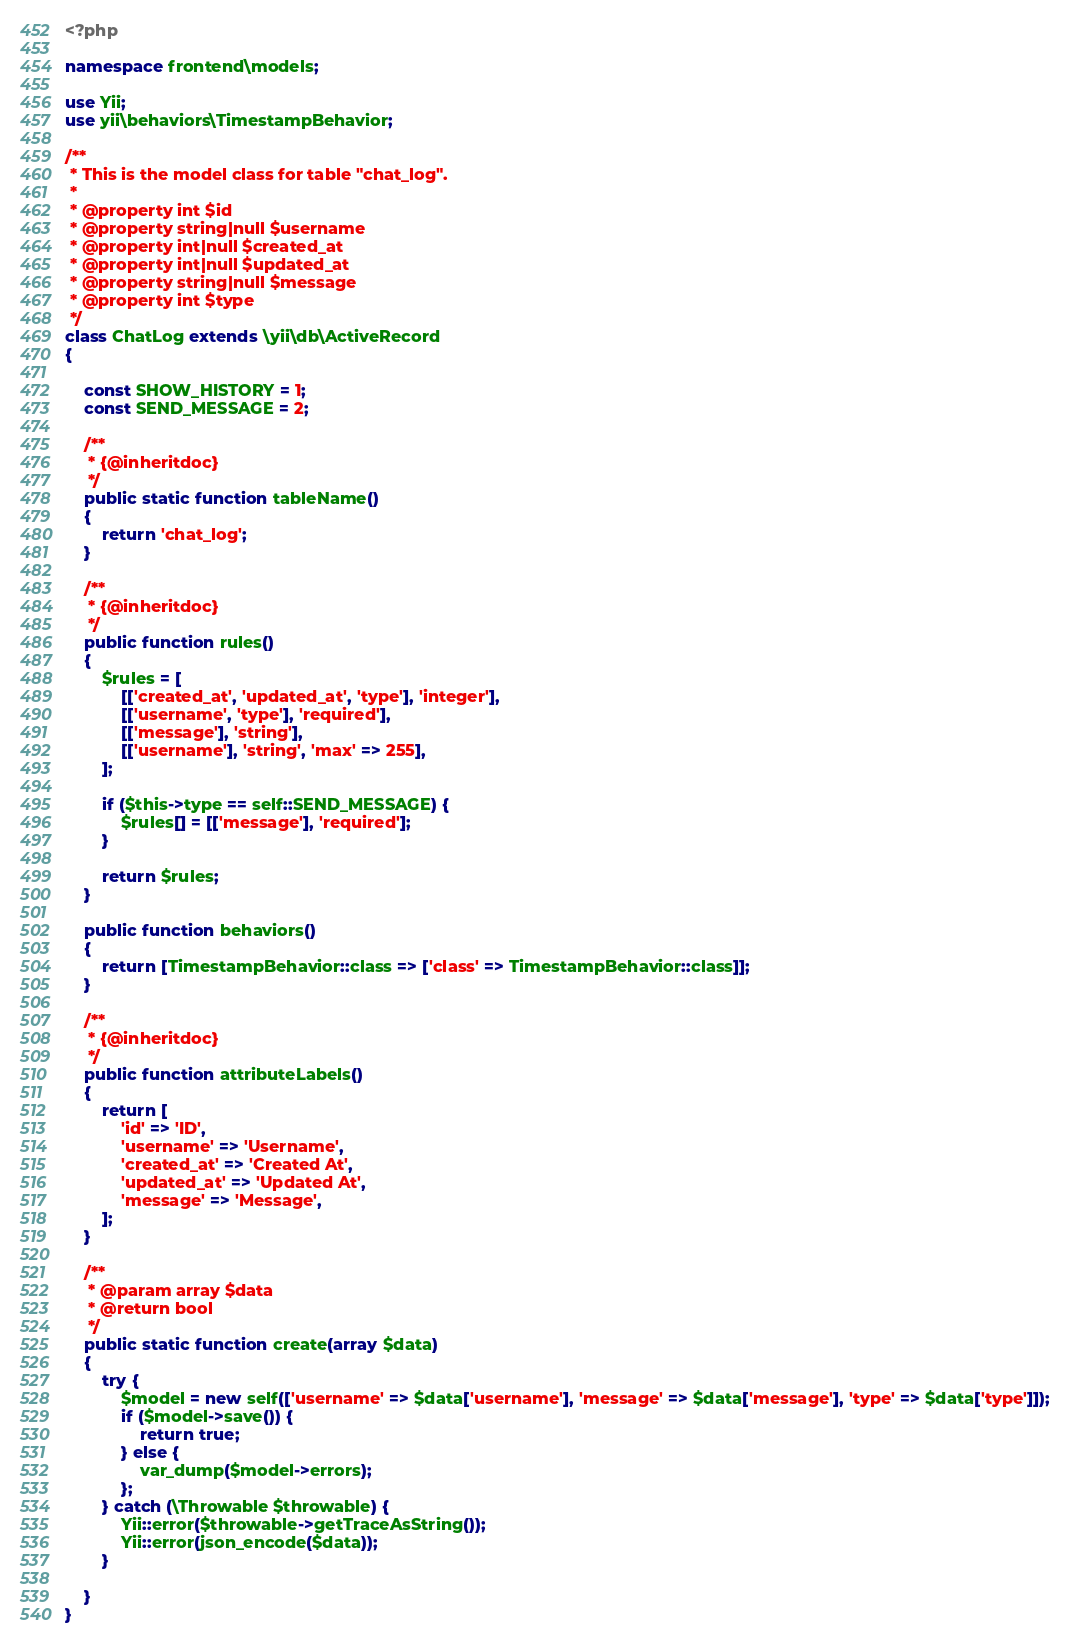<code> <loc_0><loc_0><loc_500><loc_500><_PHP_><?php

namespace frontend\models;

use Yii;
use yii\behaviors\TimestampBehavior;

/**
 * This is the model class for table "chat_log".
 *
 * @property int $id
 * @property string|null $username
 * @property int|null $created_at
 * @property int|null $updated_at
 * @property string|null $message
 * @property int $type
 */
class ChatLog extends \yii\db\ActiveRecord
{

    const SHOW_HISTORY = 1;
    const SEND_MESSAGE = 2;

    /**
     * {@inheritdoc}
     */
    public static function tableName()
    {
        return 'chat_log';
    }

    /**
     * {@inheritdoc}
     */
    public function rules()
    {
        $rules = [
            [['created_at', 'updated_at', 'type'], 'integer'],
            [['username', 'type'], 'required'],
            [['message'], 'string'],
            [['username'], 'string', 'max' => 255],
        ];

        if ($this->type == self::SEND_MESSAGE) {
            $rules[] = [['message'], 'required'];
        }

        return $rules;
    }

    public function behaviors()
    {
        return [TimestampBehavior::class => ['class' => TimestampBehavior::class]];
    }

    /**
     * {@inheritdoc}
     */
    public function attributeLabels()
    {
        return [
            'id' => 'ID',
            'username' => 'Username',
            'created_at' => 'Created At',
            'updated_at' => 'Updated At',
            'message' => 'Message',
        ];
    }

    /**
     * @param array $data
     * @return bool
     */
    public static function create(array $data)
    {
        try {
            $model = new self(['username' => $data['username'], 'message' => $data['message'], 'type' => $data['type']]);
            if ($model->save()) {
                return true;
            } else {
                var_dump($model->errors);
            };
        } catch (\Throwable $throwable) {
            Yii::error($throwable->getTraceAsString());
            Yii::error(json_encode($data));
        }

    }
}</code> 